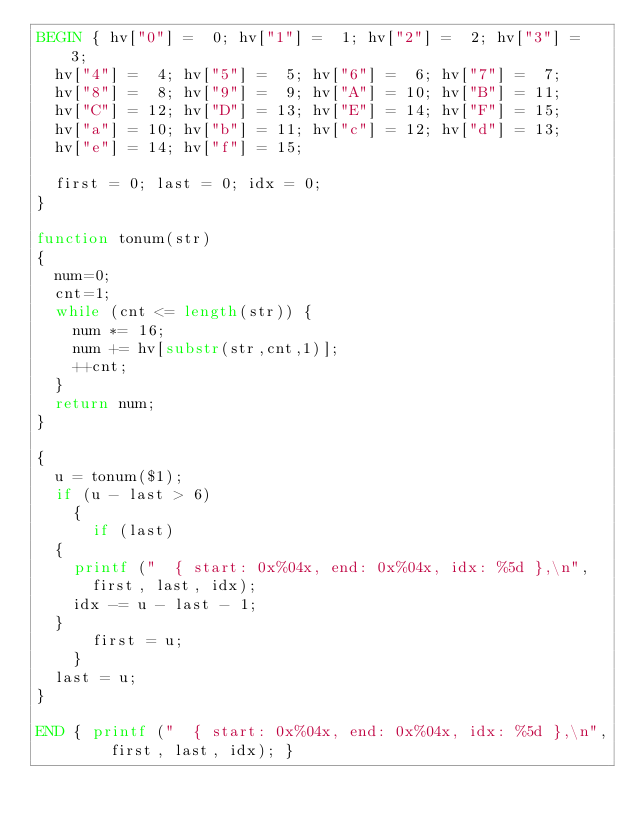<code> <loc_0><loc_0><loc_500><loc_500><_Awk_>BEGIN { hv["0"] =  0; hv["1"] =  1; hv["2"] =  2; hv["3"] =  3;
	hv["4"] =  4; hv["5"] =  5; hv["6"] =  6; hv["7"] =  7;
	hv["8"] =  8; hv["9"] =  9; hv["A"] = 10; hv["B"] = 11;
	hv["C"] = 12; hv["D"] = 13; hv["E"] = 14; hv["F"] = 15;
	hv["a"] = 10; hv["b"] = 11; hv["c"] = 12; hv["d"] = 13;
	hv["e"] = 14; hv["f"] = 15;

	first = 0; last = 0; idx = 0;
}

function tonum(str)
{
  num=0;
  cnt=1;
  while (cnt <= length(str)) {
    num *= 16;
    num += hv[substr(str,cnt,1)];
    ++cnt;
  }
  return num;
}

{
  u = tonum($1);
  if (u - last > 6)
    {
      if (last)
	{
	  printf ("  { start: 0x%04x, end: 0x%04x, idx: %5d },\n",
		  first, last, idx);
	  idx -= u - last - 1;
	}
      first = u;
    }
  last = u;
}

END { printf ("  { start: 0x%04x, end: 0x%04x, idx: %5d },\n",
	      first, last, idx); }
</code> 